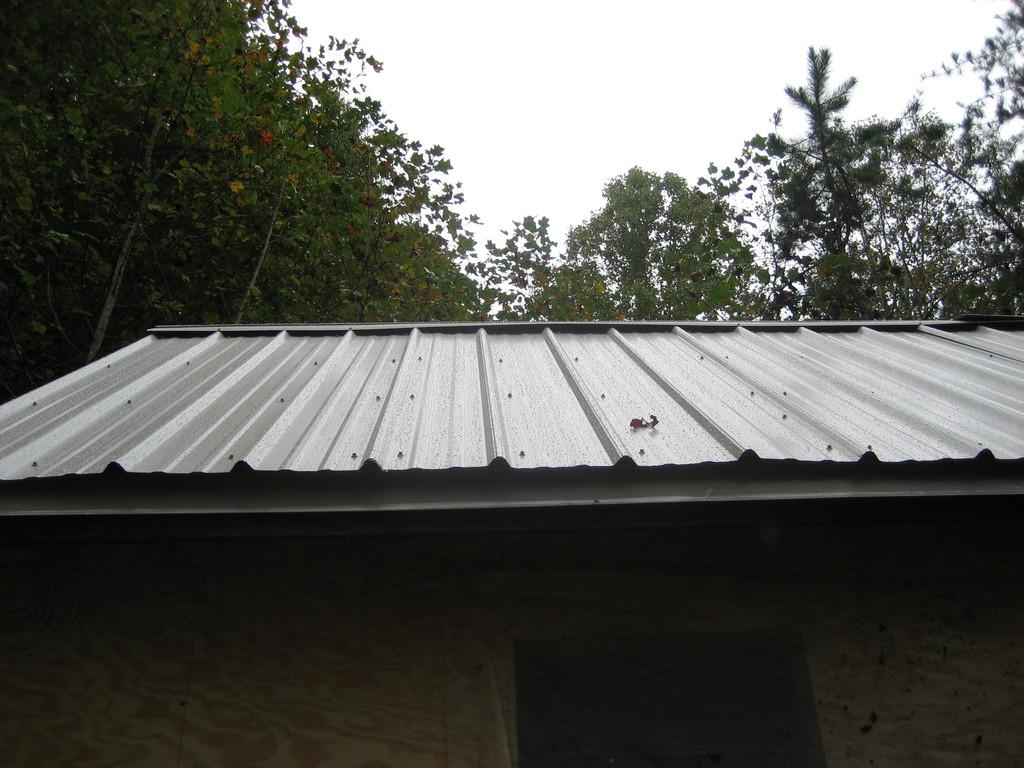What type of structure is visible in the image? There is a shed in the image. What can be seen behind the shed? There are many trees behind the shed. What is the interest rate on the loan for the shed in the image? There is no information about a loan or interest rate in the image. 